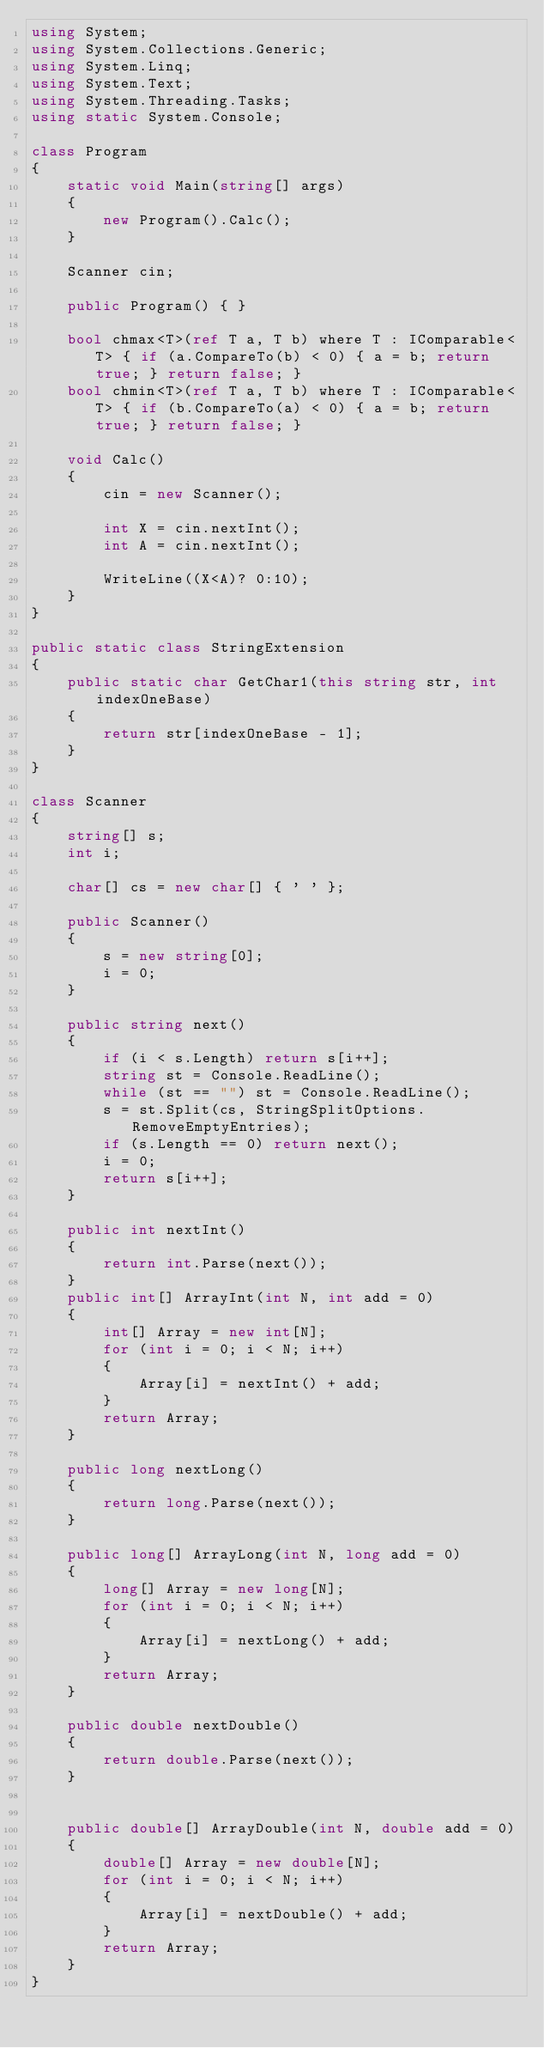Convert code to text. <code><loc_0><loc_0><loc_500><loc_500><_C#_>using System;
using System.Collections.Generic;
using System.Linq;
using System.Text;
using System.Threading.Tasks;
using static System.Console;

class Program
{
    static void Main(string[] args)
    {
        new Program().Calc();
    }

    Scanner cin;

    public Program() { }

    bool chmax<T>(ref T a, T b) where T : IComparable<T> { if (a.CompareTo(b) < 0) { a = b; return true; } return false; }
    bool chmin<T>(ref T a, T b) where T : IComparable<T> { if (b.CompareTo(a) < 0) { a = b; return true; } return false; }

    void Calc()
    {
        cin = new Scanner();

        int X = cin.nextInt();
        int A = cin.nextInt();

        WriteLine((X<A)? 0:10);
    }
}

public static class StringExtension
{
    public static char GetChar1(this string str, int indexOneBase)
    {
        return str[indexOneBase - 1];
    }
}

class Scanner
{
    string[] s;
    int i;

    char[] cs = new char[] { ' ' };

    public Scanner()
    {
        s = new string[0];
        i = 0;
    }

    public string next()
    {
        if (i < s.Length) return s[i++];
        string st = Console.ReadLine();
        while (st == "") st = Console.ReadLine();
        s = st.Split(cs, StringSplitOptions.RemoveEmptyEntries);
        if (s.Length == 0) return next();
        i = 0;
        return s[i++];
    }

    public int nextInt()
    {
        return int.Parse(next());
    }
    public int[] ArrayInt(int N, int add = 0)
    {
        int[] Array = new int[N];
        for (int i = 0; i < N; i++)
        {
            Array[i] = nextInt() + add;
        }
        return Array;
    }

    public long nextLong()
    {
        return long.Parse(next());
    }

    public long[] ArrayLong(int N, long add = 0)
    {
        long[] Array = new long[N];
        for (int i = 0; i < N; i++)
        {
            Array[i] = nextLong() + add;
        }
        return Array;
    }

    public double nextDouble()
    {
        return double.Parse(next());
    }


    public double[] ArrayDouble(int N, double add = 0)
    {
        double[] Array = new double[N];
        for (int i = 0; i < N; i++)
        {
            Array[i] = nextDouble() + add;
        }
        return Array;
    }
}
</code> 